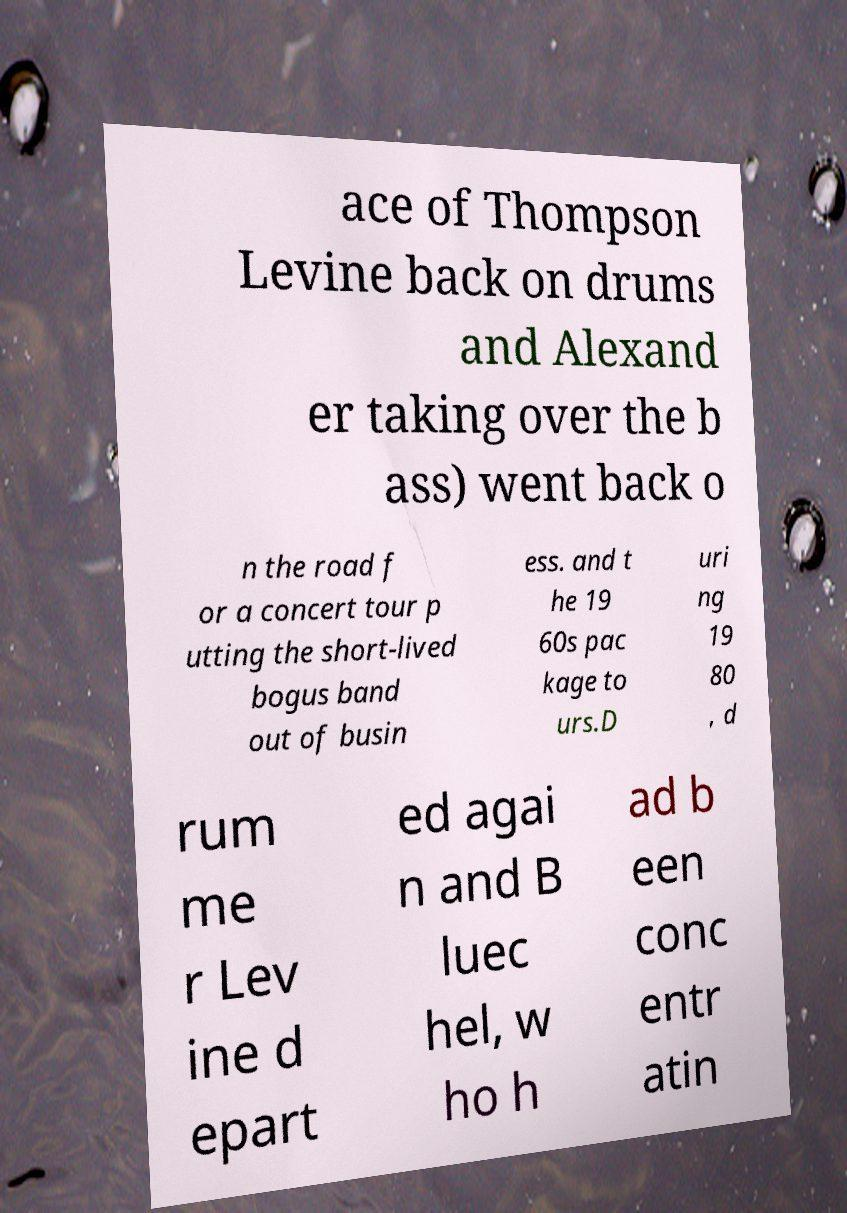Could you extract and type out the text from this image? ace of Thompson Levine back on drums and Alexand er taking over the b ass) went back o n the road f or a concert tour p utting the short-lived bogus band out of busin ess. and t he 19 60s pac kage to urs.D uri ng 19 80 , d rum me r Lev ine d epart ed agai n and B luec hel, w ho h ad b een conc entr atin 